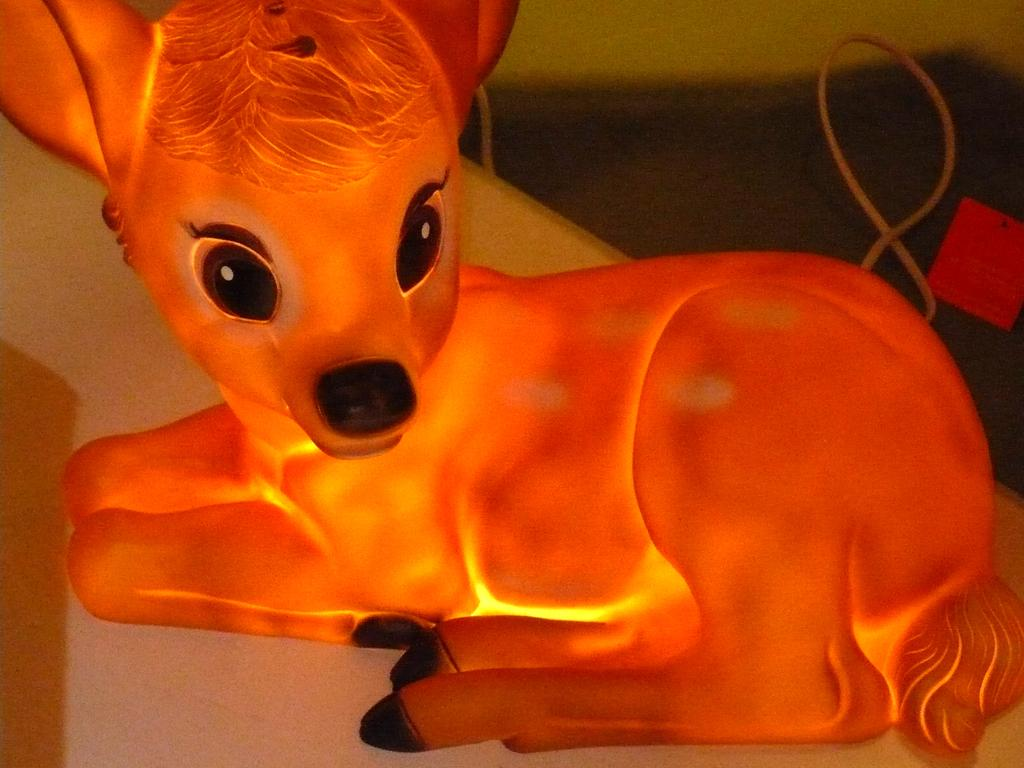What type of object is in the image that resembles an animal? There is an animal-shaped toy in the image. What colors can be seen on the toy? The toy is orange, black, and yellow in color. What is the color of the surface the toy is placed on? The toy is on a white-colored surface. What other color is present in the image besides the colors of the toy? There is a red-colored object in the image. What type of material can be seen in the image? There are ropes visible in the image. What type of meat is being prepared on the curtain in the image? There is no meat or curtain present in the image; it features an animal-shaped toy on a white surface, a red-colored object, and ropes. 